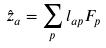<formula> <loc_0><loc_0><loc_500><loc_500>\hat { z } _ { a } = \sum _ { p } l _ { a p } F _ { p }</formula> 